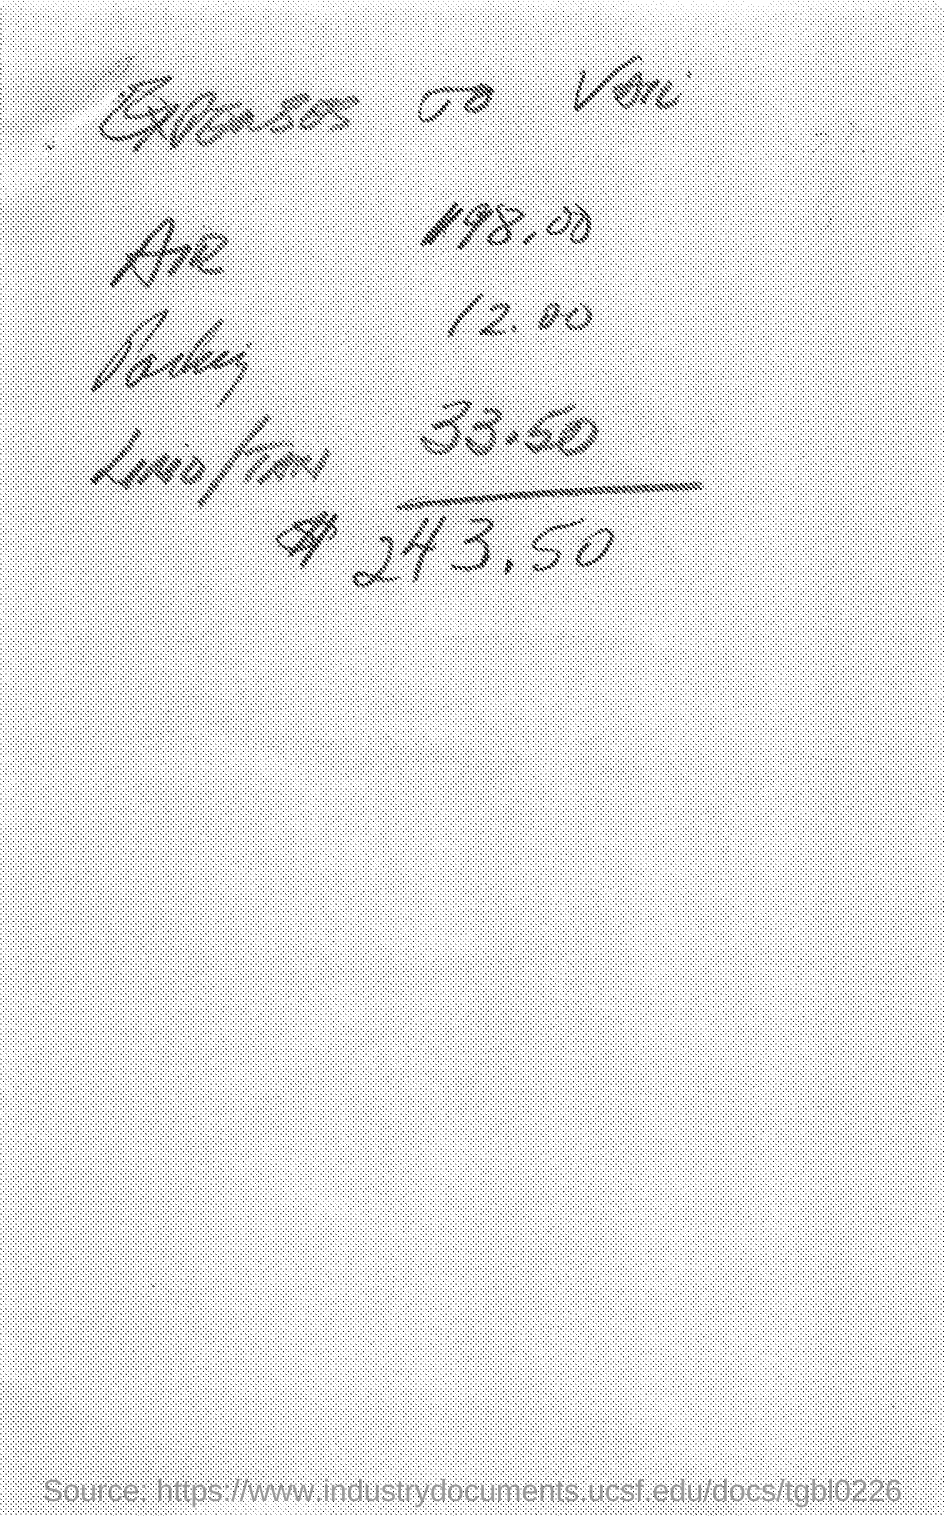What are expenses of air?
Provide a short and direct response. 198.00. 